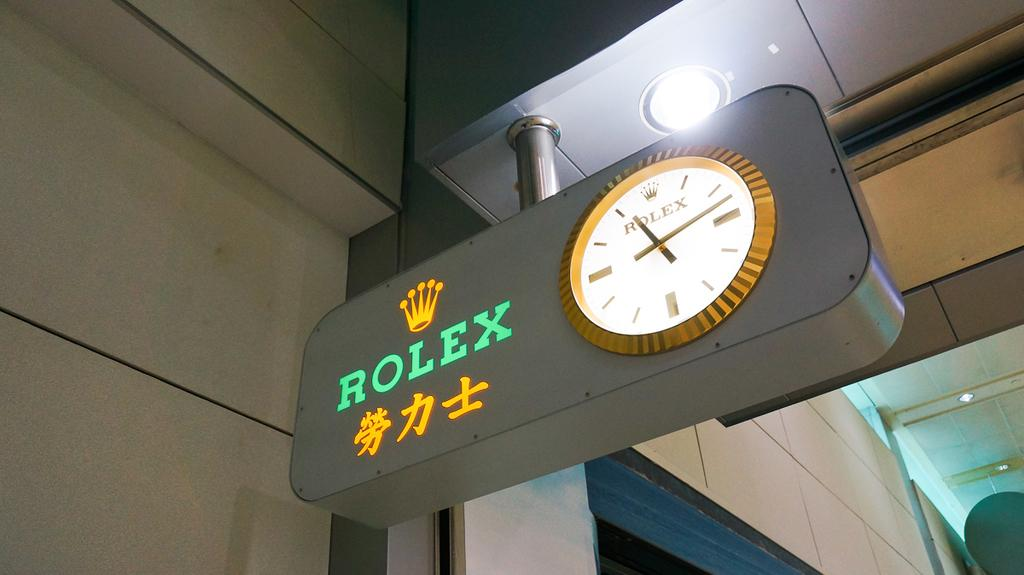Provide a one-sentence caption for the provided image. Rolex roman numeral clock that is gold and white. 